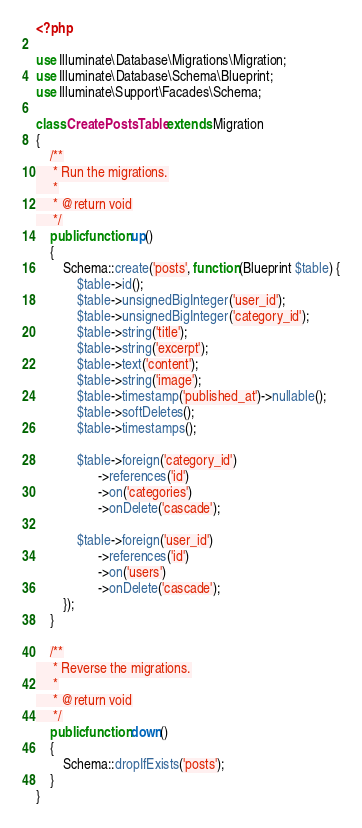Convert code to text. <code><loc_0><loc_0><loc_500><loc_500><_PHP_><?php

use Illuminate\Database\Migrations\Migration;
use Illuminate\Database\Schema\Blueprint;
use Illuminate\Support\Facades\Schema;

class CreatePostsTable extends Migration
{
    /**
     * Run the migrations.
     *
     * @return void
     */
    public function up()
    {
        Schema::create('posts', function (Blueprint $table) {
            $table->id();
            $table->unsignedBigInteger('user_id');
            $table->unsignedBigInteger('category_id');
            $table->string('title');
            $table->string('excerpt');
            $table->text('content');
            $table->string('image');
            $table->timestamp('published_at')->nullable();
            $table->softDeletes();
            $table->timestamps();

            $table->foreign('category_id')
                  ->references('id')
                  ->on('categories')
                  ->onDelete('cascade');

            $table->foreign('user_id')
                  ->references('id')
                  ->on('users')
                  ->onDelete('cascade');
        });
    }

    /**
     * Reverse the migrations.
     *
     * @return void
     */
    public function down()
    {
        Schema::dropIfExists('posts');
    }
}
</code> 